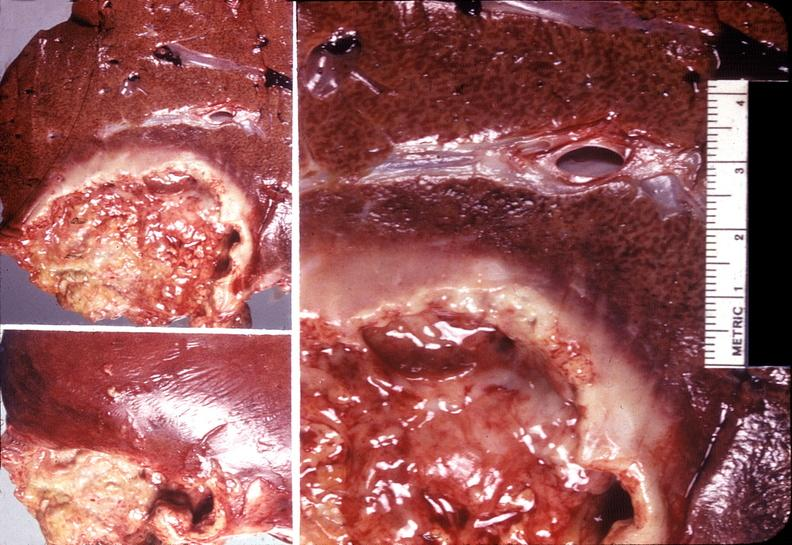what does this image show?
Answer the question using a single word or phrase. Liver 